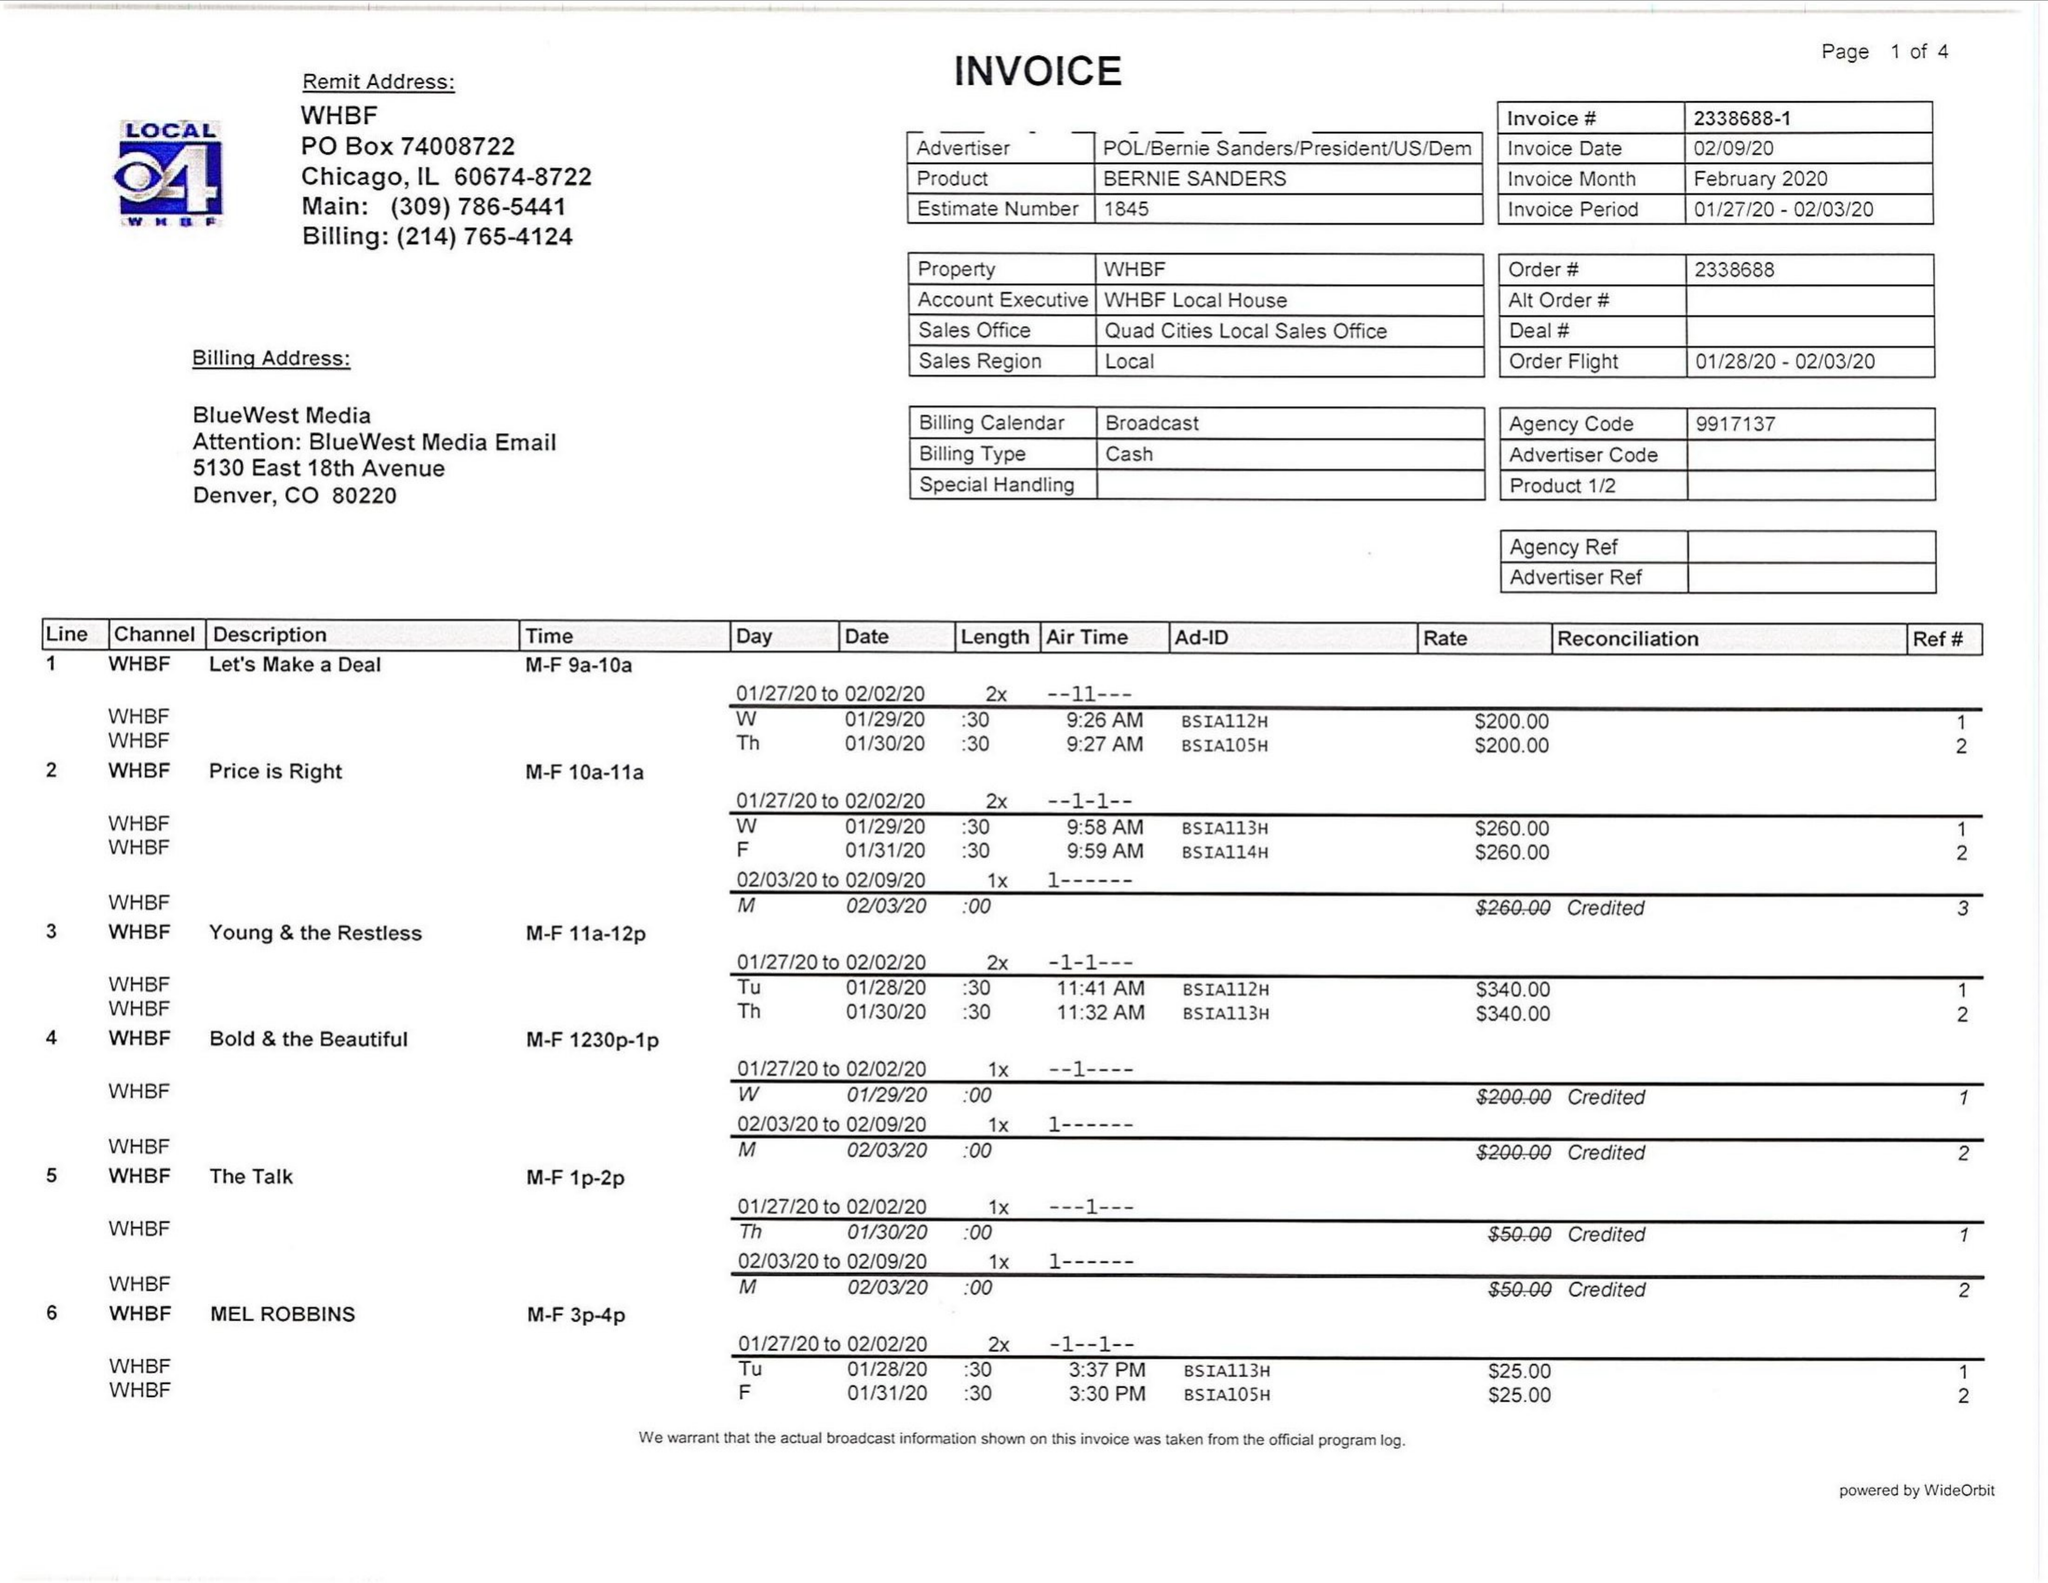What is the value for the flight_from?
Answer the question using a single word or phrase. 01/28/20 